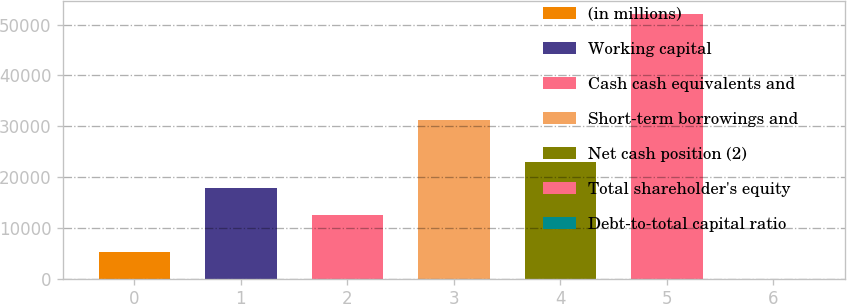Convert chart. <chart><loc_0><loc_0><loc_500><loc_500><bar_chart><fcel>(in millions)<fcel>Working capital<fcel>Cash cash equivalents and<fcel>Short-term borrowings and<fcel>Net cash position (2)<fcel>Total shareholder's equity<fcel>Debt-to-total capital ratio<nl><fcel>5240.5<fcel>17836.5<fcel>12634<fcel>31240<fcel>23039<fcel>52063<fcel>38<nl></chart> 